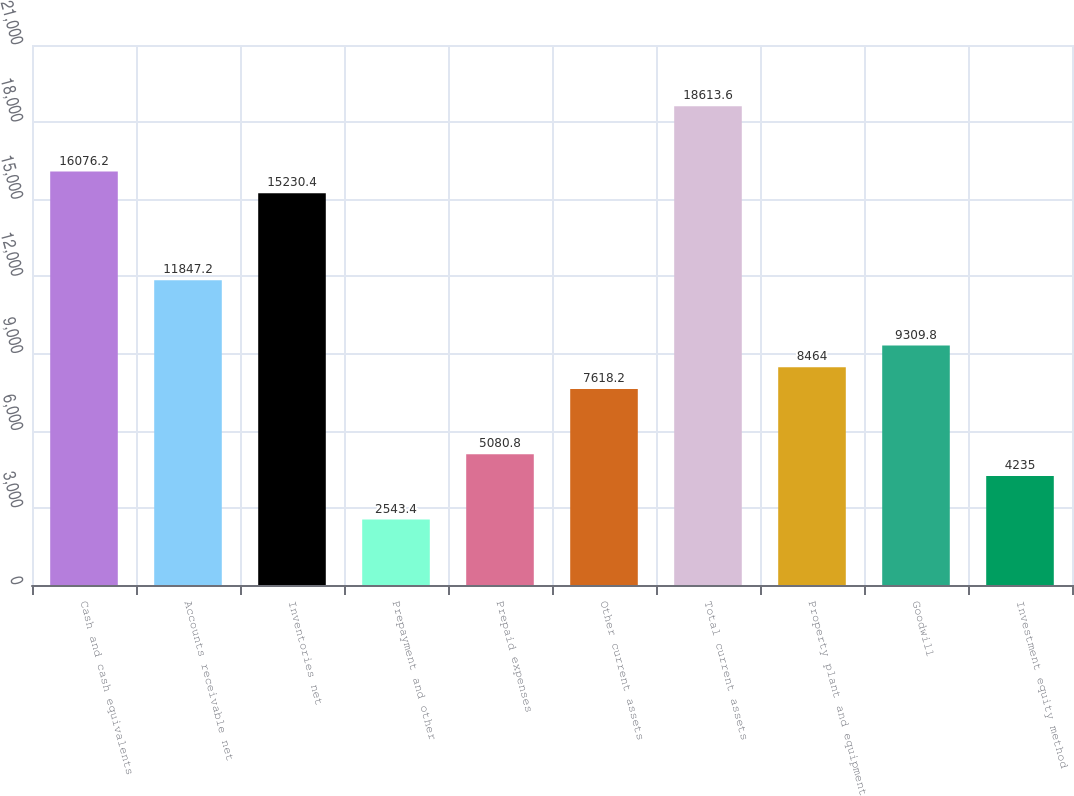<chart> <loc_0><loc_0><loc_500><loc_500><bar_chart><fcel>Cash and cash equivalents<fcel>Accounts receivable net<fcel>Inventories net<fcel>Prepayment and other<fcel>Prepaid expenses<fcel>Other current assets<fcel>Total current assets<fcel>Property plant and equipment<fcel>Goodwill<fcel>Investment equity method<nl><fcel>16076.2<fcel>11847.2<fcel>15230.4<fcel>2543.4<fcel>5080.8<fcel>7618.2<fcel>18613.6<fcel>8464<fcel>9309.8<fcel>4235<nl></chart> 